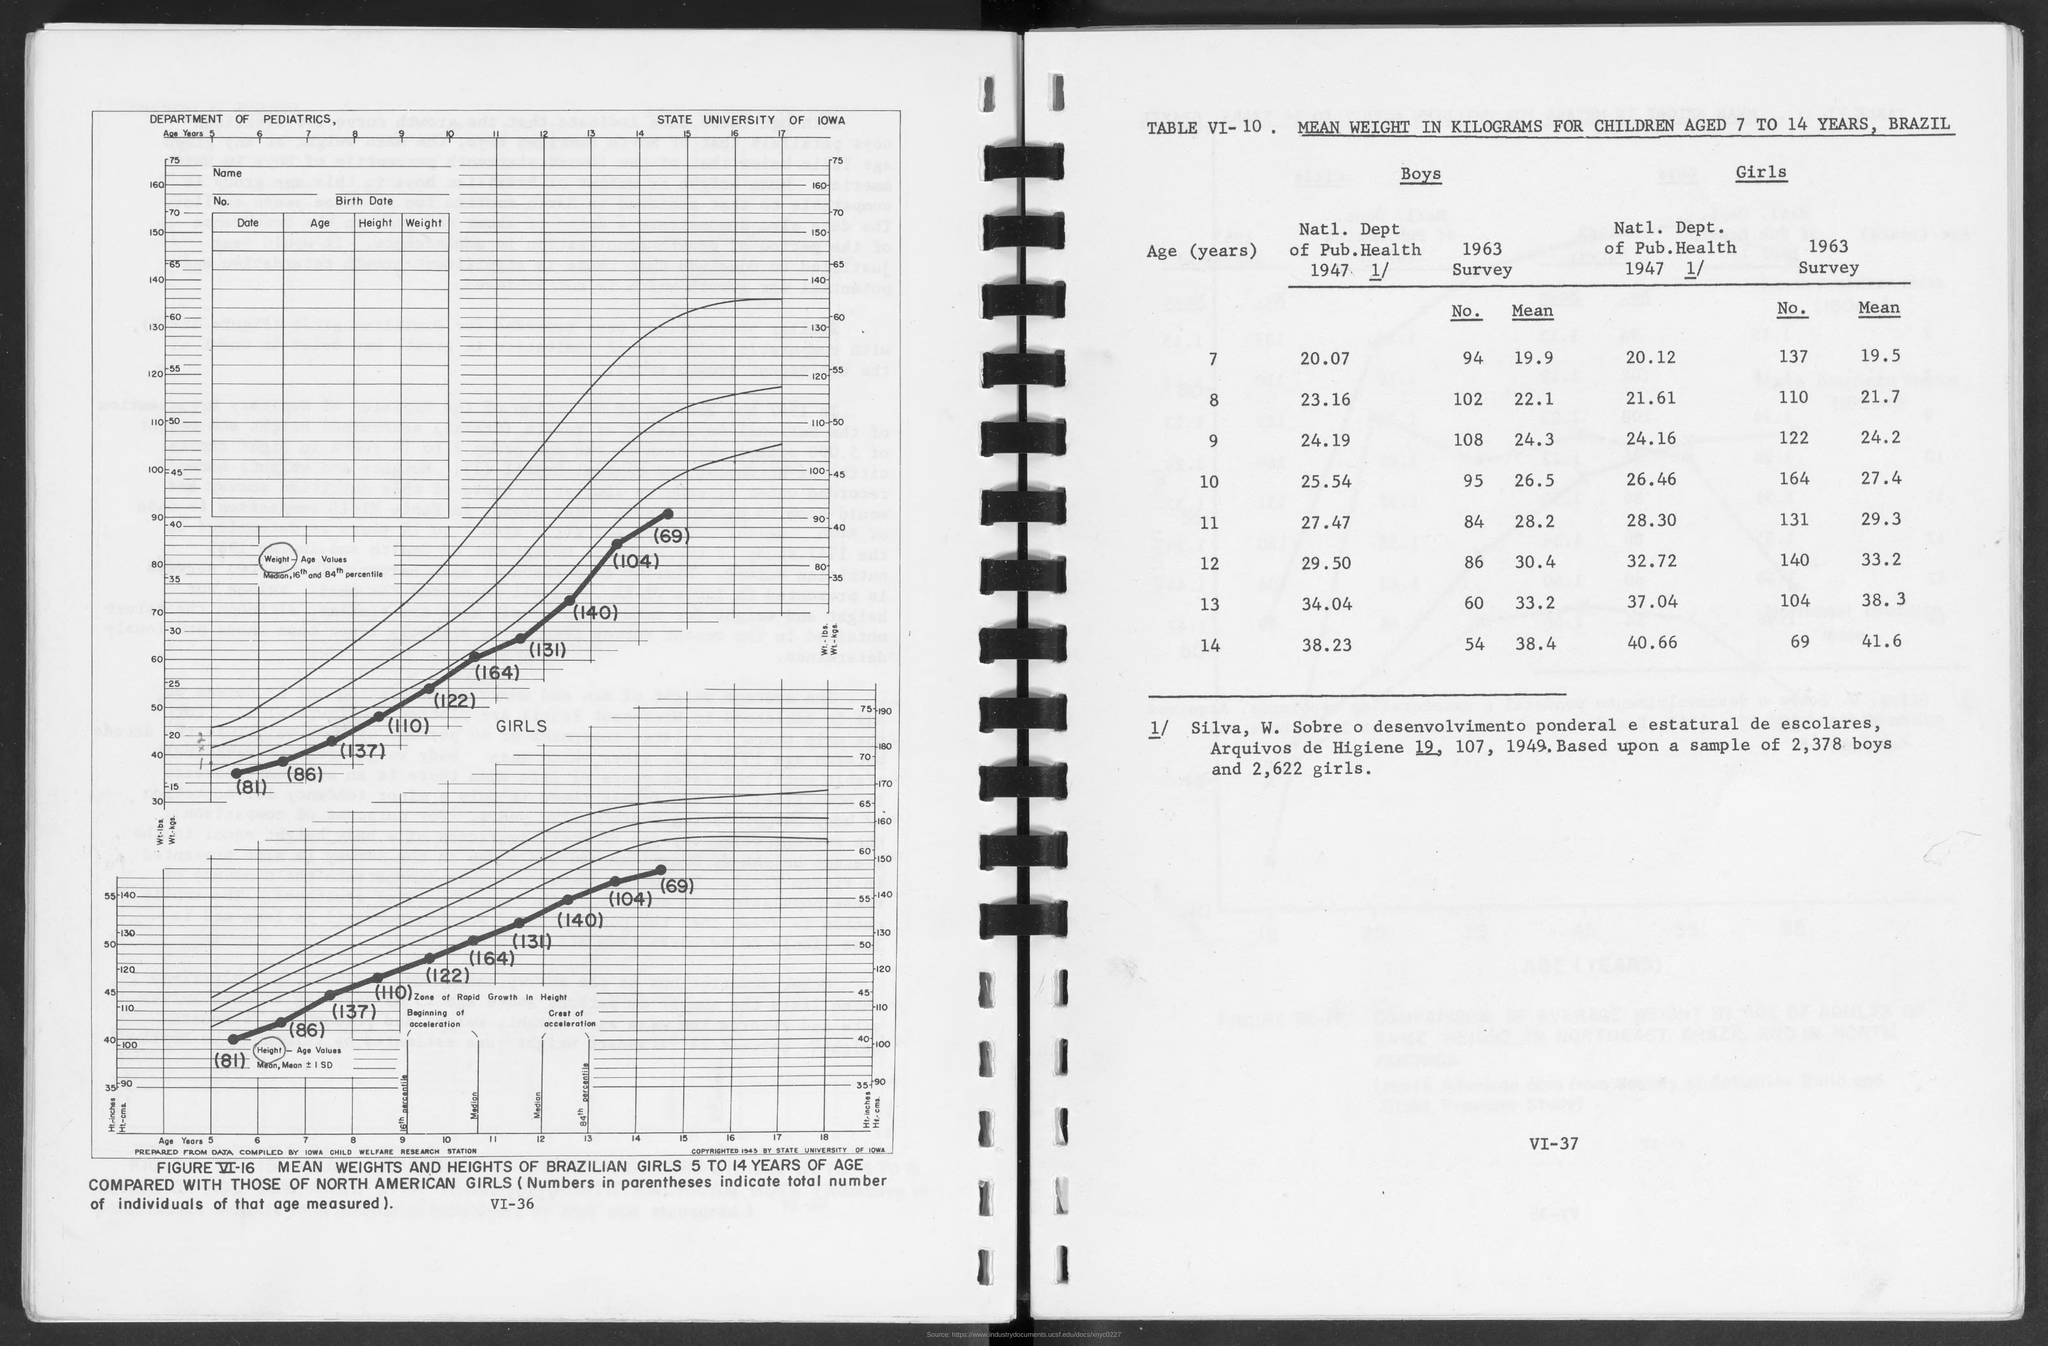Which department has come up with the study?
Provide a succinct answer. DEPARTMENT OF PEDIATRICS. Which university is mentioned?
Your response must be concise. STATE UNIVERSITY OF IOWA. What is the title of table VI-10?
Ensure brevity in your answer.  MEAN WEIGHT IN KILOGRAMS FOR CHILDREN AGED 7 TO 14 YEARS, BRAZIL. 